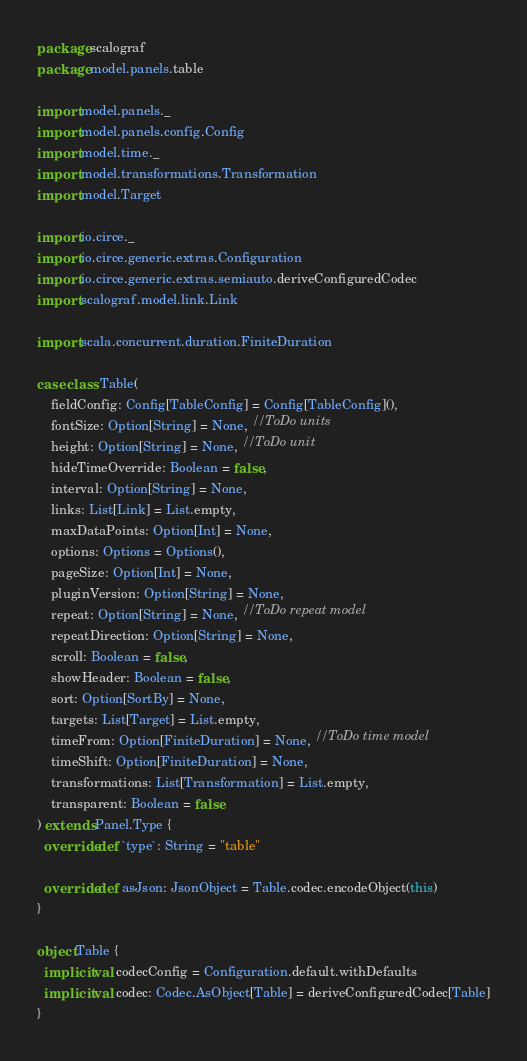Convert code to text. <code><loc_0><loc_0><loc_500><loc_500><_Scala_>package scalograf
package model.panels.table

import model.panels._
import model.panels.config.Config
import model.time._
import model.transformations.Transformation
import model.Target

import io.circe._
import io.circe.generic.extras.Configuration
import io.circe.generic.extras.semiauto.deriveConfiguredCodec
import scalograf.model.link.Link

import scala.concurrent.duration.FiniteDuration

case class Table(
    fieldConfig: Config[TableConfig] = Config[TableConfig](),
    fontSize: Option[String] = None, //ToDo units
    height: Option[String] = None, //ToDo unit
    hideTimeOverride: Boolean = false,
    interval: Option[String] = None,
    links: List[Link] = List.empty,
    maxDataPoints: Option[Int] = None,
    options: Options = Options(),
    pageSize: Option[Int] = None,
    pluginVersion: Option[String] = None,
    repeat: Option[String] = None, //ToDo repeat model
    repeatDirection: Option[String] = None,
    scroll: Boolean = false,
    showHeader: Boolean = false,
    sort: Option[SortBy] = None,
    targets: List[Target] = List.empty,
    timeFrom: Option[FiniteDuration] = None, //ToDo time model
    timeShift: Option[FiniteDuration] = None,
    transformations: List[Transformation] = List.empty,
    transparent: Boolean = false
) extends Panel.Type {
  override def `type`: String = "table"

  override def asJson: JsonObject = Table.codec.encodeObject(this)
}

object Table {
  implicit val codecConfig = Configuration.default.withDefaults
  implicit val codec: Codec.AsObject[Table] = deriveConfiguredCodec[Table]
}
</code> 